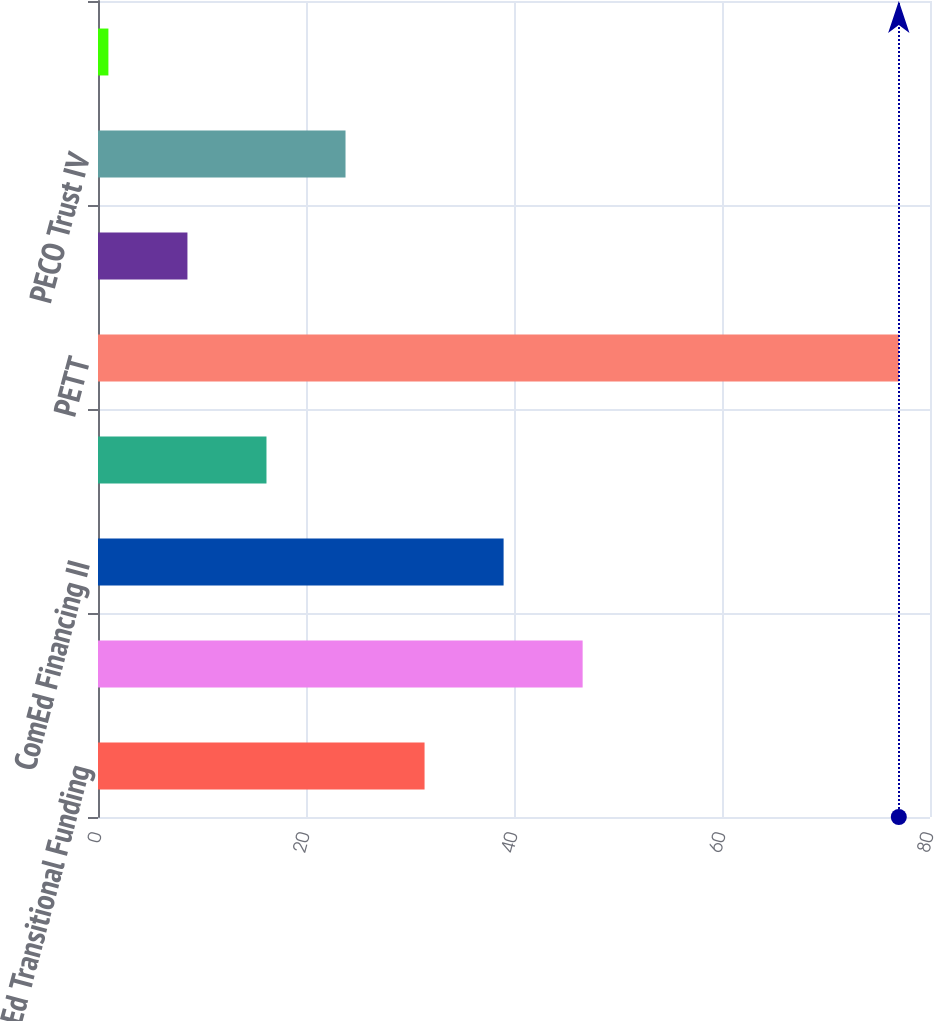Convert chart to OTSL. <chart><loc_0><loc_0><loc_500><loc_500><bar_chart><fcel>ComEd Transitional Funding<fcel>ComEd Transitional Funding LLC<fcel>ComEd Financing II<fcel>ComEd Financing III<fcel>PETT<fcel>PECO Energy Capital Corp<fcel>PECO Trust IV<fcel>PECO Trust III<nl><fcel>31.4<fcel>46.6<fcel>39<fcel>16.2<fcel>77<fcel>8.6<fcel>23.8<fcel>1<nl></chart> 